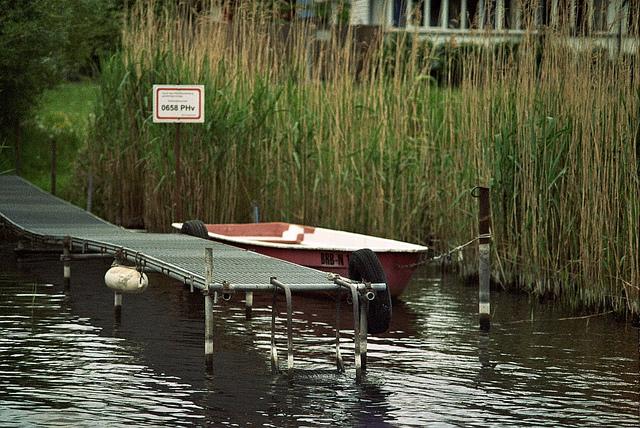Is there anyone in the boat?
Write a very short answer. No. How many tires are in the picture?
Answer briefly. 2. What is growing behind the boat?
Keep it brief. Reeds. 